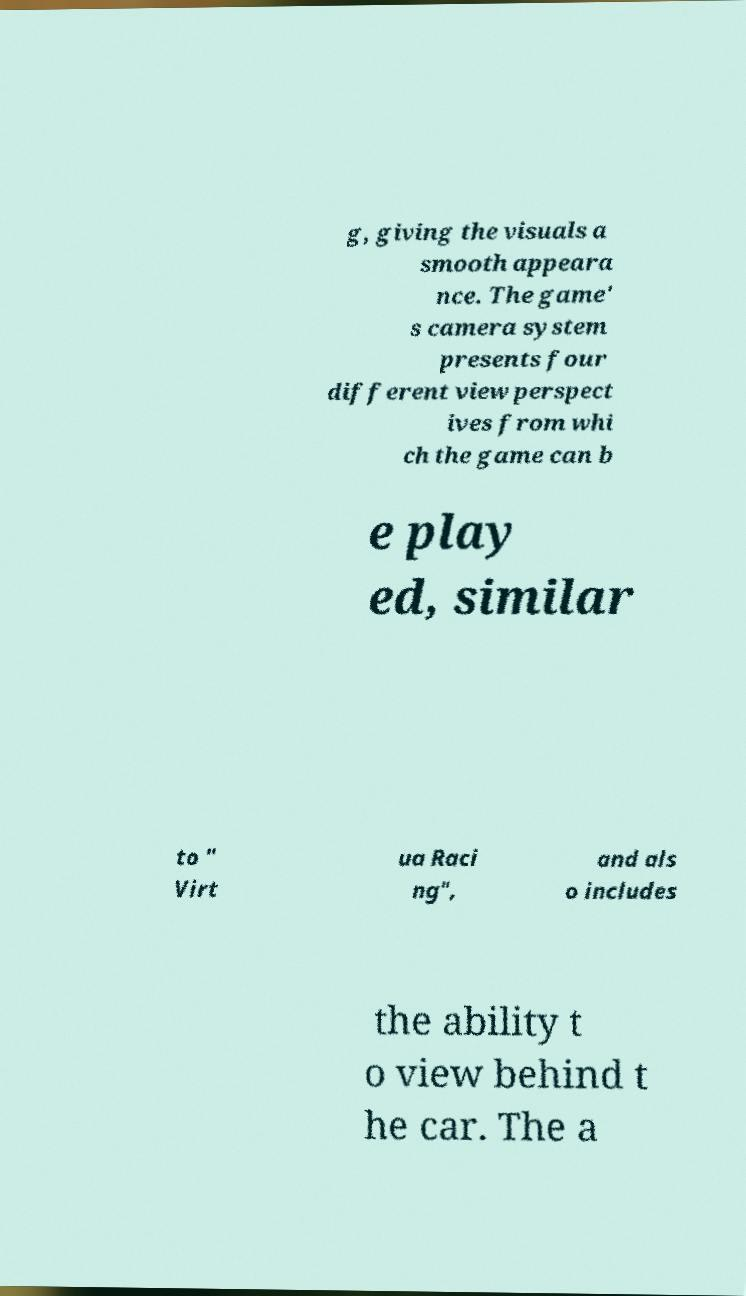For documentation purposes, I need the text within this image transcribed. Could you provide that? g, giving the visuals a smooth appeara nce. The game' s camera system presents four different view perspect ives from whi ch the game can b e play ed, similar to " Virt ua Raci ng", and als o includes the ability t o view behind t he car. The a 